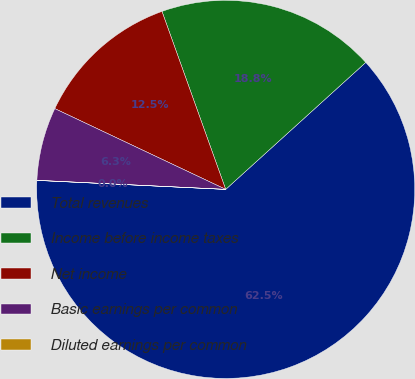<chart> <loc_0><loc_0><loc_500><loc_500><pie_chart><fcel>Total revenues<fcel>Income before income taxes<fcel>Net income<fcel>Basic earnings per common<fcel>Diluted earnings per common<nl><fcel>62.47%<fcel>18.75%<fcel>12.5%<fcel>6.26%<fcel>0.01%<nl></chart> 